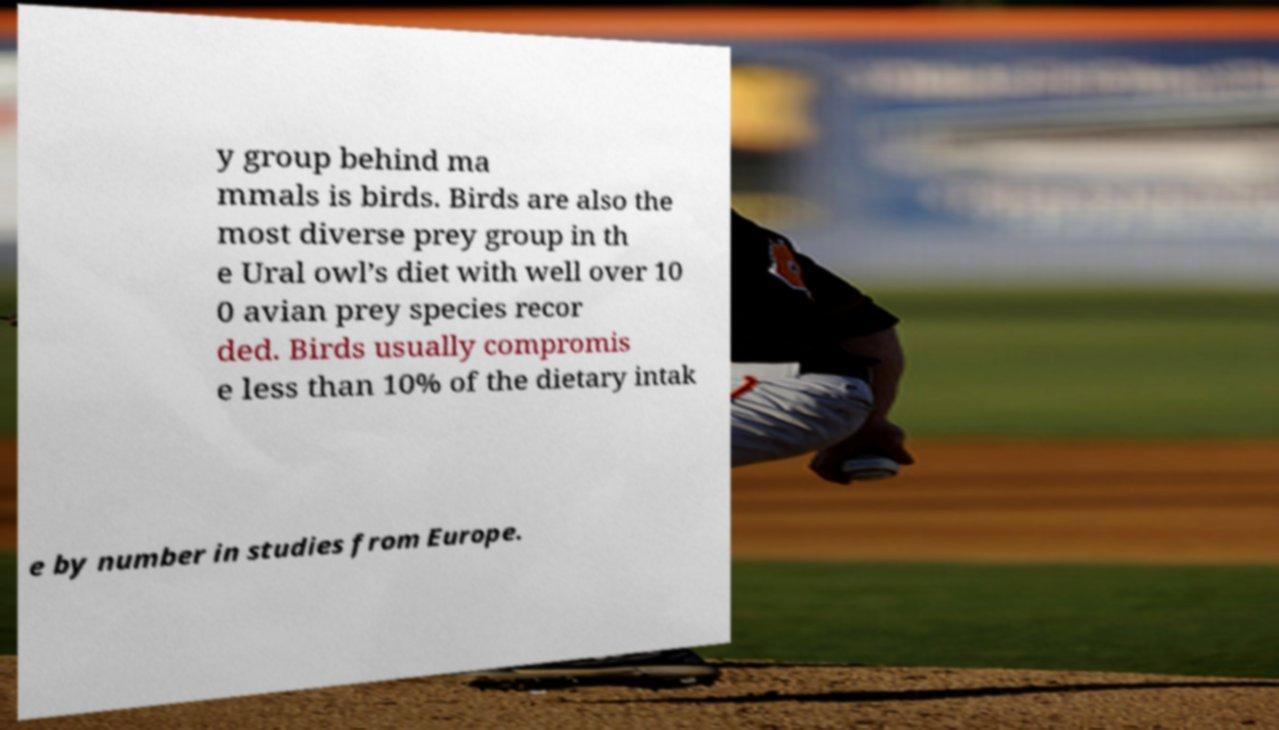Please identify and transcribe the text found in this image. y group behind ma mmals is birds. Birds are also the most diverse prey group in th e Ural owl’s diet with well over 10 0 avian prey species recor ded. Birds usually compromis e less than 10% of the dietary intak e by number in studies from Europe. 